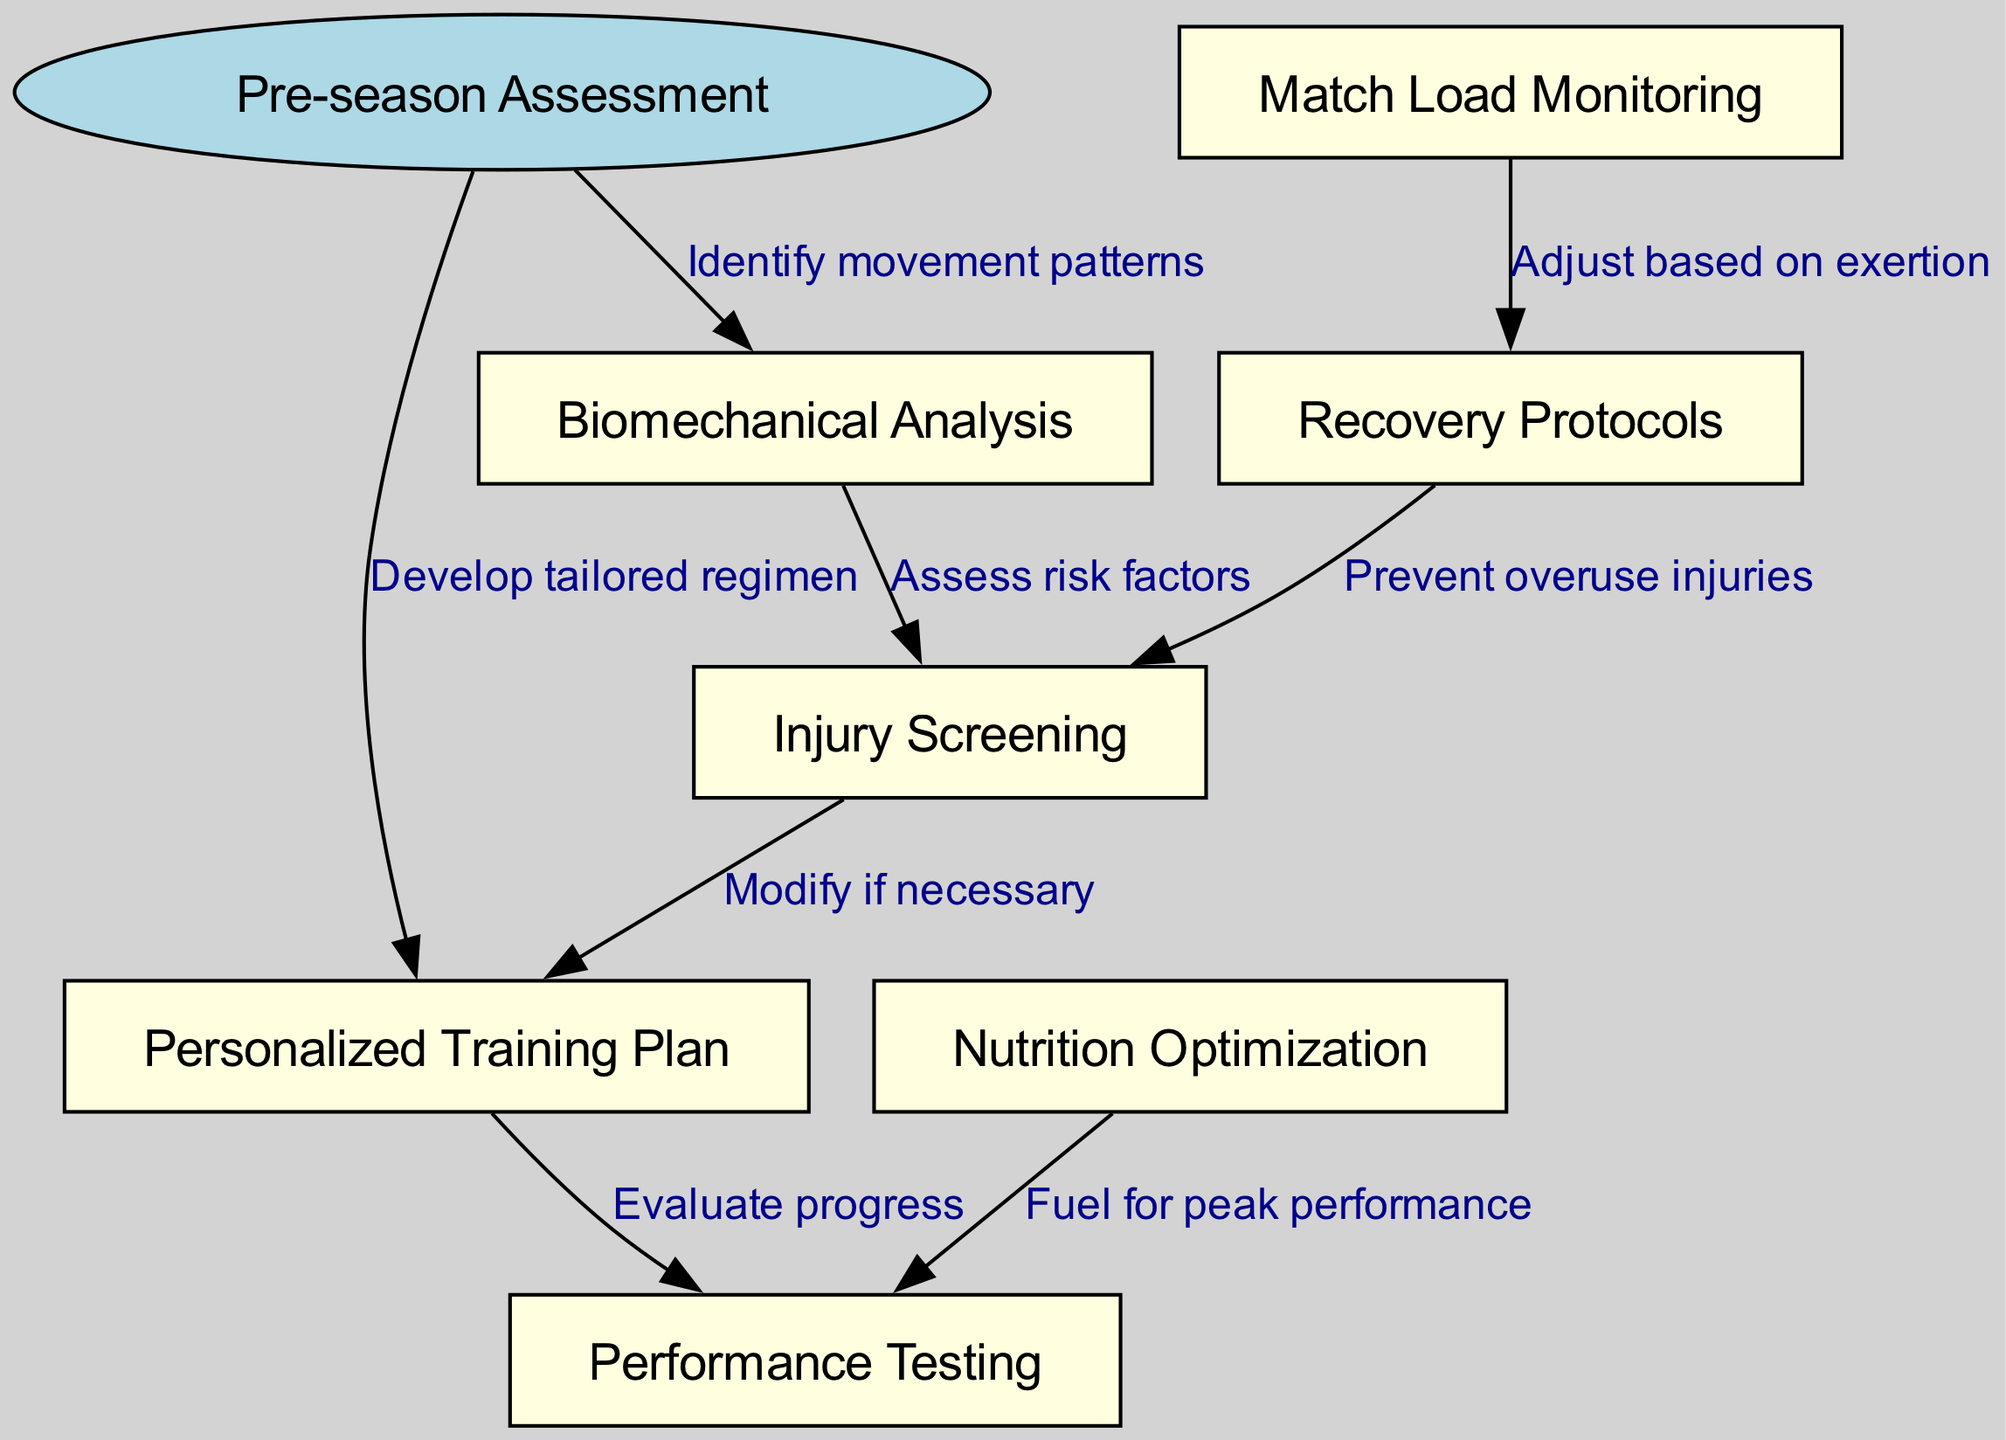What is the starting node of the pathway? The starting node, as indicated in the diagram, is labeled "Pre-season Assessment." Thus, it does not require any further connections to determine; it is explicitly stated at the beginning of the pathway.
Answer: Pre-season Assessment How many nodes are present in the diagram? To find the total number of nodes, count all the distinct elements including the starting node and the subsequent analysis steps. There is 1 starting node and 6 additional nodes, giving a total of 7 nodes.
Answer: 7 What action is taken after "Biomechanical Analysis"? Following "Biomechanical Analysis" in the pathway, the next step taken is "Injury Screening," as depicted by a direct arrow connecting these two nodes.
Answer: Injury Screening What is the purpose of "Match Load Monitoring"? The purpose, as defined by the outgoing edge in the diagram, is to "Adjust based on exertion" which indicates that this step helps manage players' training intensity or engagement during the tournament.
Answer: Adjust based on exertion What nodes connect to "Performance Testing"? "Performance Testing" is connected from two other nodes: "Personalized Training Plan" and "Nutrition Optimization." This means both of these aspects contribute to evaluating the player's performance.
Answer: Personalized Training Plan, Nutrition Optimization What does "Recovery Protocols" connect to? According to the diagram, "Recovery Protocols" connects to two nodes: "Match Load Monitoring" and "Injury Screening," suggesting that these interactions are crucial for managing player recovery effectively and preventing injuries.
Answer: Match Load Monitoring, Injury Screening Which node is reached after "Injury Screening"? After "Injury Screening," the pathway indicates a connection back to "Personalized Training Plan," which signifies that insights gained from injury prevention may necessitate adjustments to the training regimen.
Answer: Personalized Training Plan What is the relation of "Nutrition Optimization" to "Performance Testing"? The relationship is indicated by the connecting edge labeled "Fuel for peak performance," which conveys that proper nutrition directly contributes to the outcomes measured in performance testing.
Answer: Fuel for peak performance 